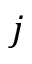Convert formula to latex. <formula><loc_0><loc_0><loc_500><loc_500>j</formula> 